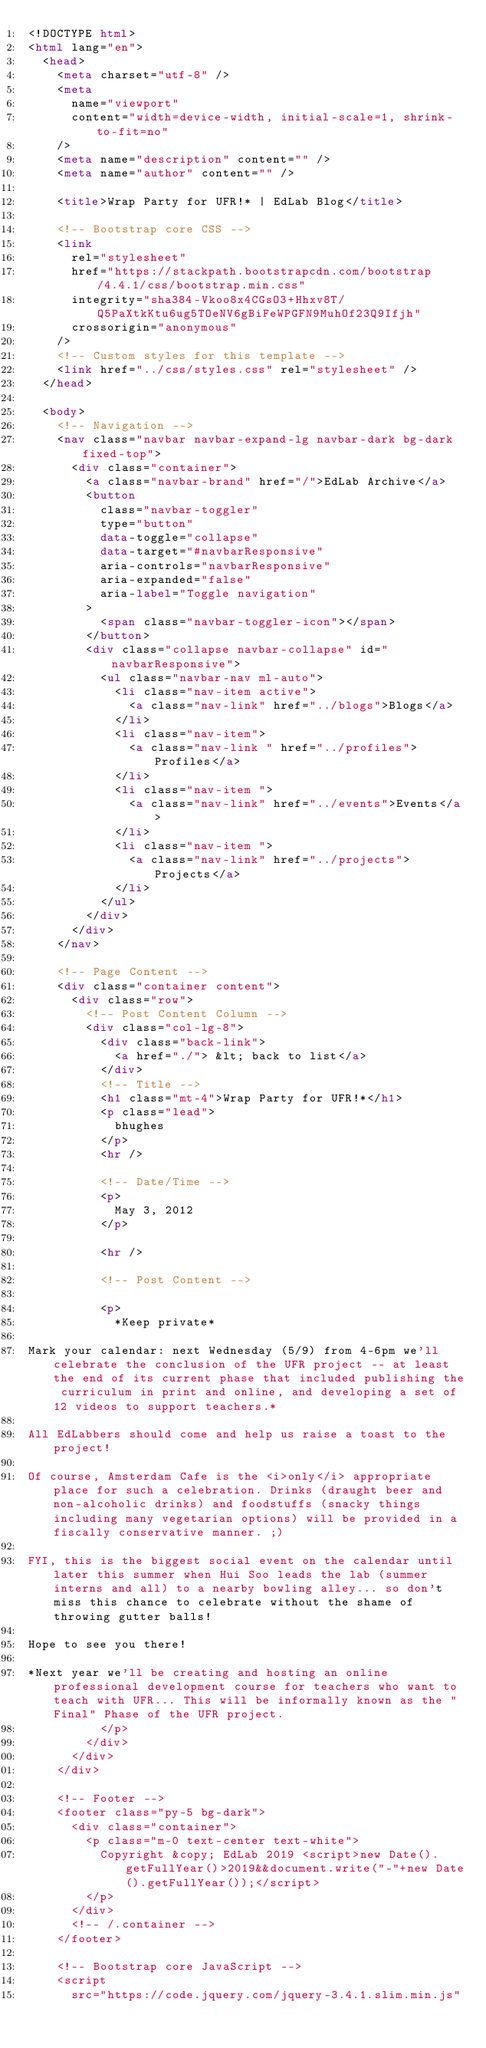Convert code to text. <code><loc_0><loc_0><loc_500><loc_500><_HTML_><!DOCTYPE html>
<html lang="en">
  <head>
    <meta charset="utf-8" />
    <meta
      name="viewport"
      content="width=device-width, initial-scale=1, shrink-to-fit=no"
    />
    <meta name="description" content="" />
    <meta name="author" content="" />

    <title>Wrap Party for UFR!* | EdLab Blog</title>

    <!-- Bootstrap core CSS -->
    <link
      rel="stylesheet"
      href="https://stackpath.bootstrapcdn.com/bootstrap/4.4.1/css/bootstrap.min.css"
      integrity="sha384-Vkoo8x4CGsO3+Hhxv8T/Q5PaXtkKtu6ug5TOeNV6gBiFeWPGFN9MuhOf23Q9Ifjh"
      crossorigin="anonymous"
    />
    <!-- Custom styles for this template -->
    <link href="../css/styles.css" rel="stylesheet" />
  </head>

  <body>
    <!-- Navigation -->
    <nav class="navbar navbar-expand-lg navbar-dark bg-dark fixed-top">
      <div class="container">
        <a class="navbar-brand" href="/">EdLab Archive</a>
        <button
          class="navbar-toggler"
          type="button"
          data-toggle="collapse"
          data-target="#navbarResponsive"
          aria-controls="navbarResponsive"
          aria-expanded="false"
          aria-label="Toggle navigation"
        >
          <span class="navbar-toggler-icon"></span>
        </button>
        <div class="collapse navbar-collapse" id="navbarResponsive">
          <ul class="navbar-nav ml-auto">
            <li class="nav-item active">
              <a class="nav-link" href="../blogs">Blogs</a>
            </li>
            <li class="nav-item">
              <a class="nav-link " href="../profiles">Profiles</a>
            </li>
            <li class="nav-item ">
              <a class="nav-link" href="../events">Events</a>
            </li>
            <li class="nav-item ">
              <a class="nav-link" href="../projects">Projects</a>
            </li>
          </ul>
        </div>
      </div>
    </nav>

    <!-- Page Content -->
    <div class="container content">
      <div class="row">
        <!-- Post Content Column -->
        <div class="col-lg-8">
          <div class="back-link">
            <a href="./"> &lt; back to list</a>
          </div>
          <!-- Title -->
          <h1 class="mt-4">Wrap Party for UFR!*</h1>
          <p class="lead">
            bhughes
          </p>
          <hr />

          <!-- Date/Time -->
          <p>
            May 3, 2012
          </p>

          <hr />

          <!-- Post Content -->

          <p>
            *Keep private*

Mark your calendar: next Wednesday (5/9) from 4-6pm we'll celebrate the conclusion of the UFR project -- at least the end of its current phase that included publishing the curriculum in print and online, and developing a set of 12 videos to support teachers.*

All EdLabbers should come and help us raise a toast to the project!

Of course, Amsterdam Cafe is the <i>only</i> appropriate place for such a celebration. Drinks (draught beer and non-alcoholic drinks) and foodstuffs (snacky things including many vegetarian options) will be provided in a fiscally conservative manner. ;)

FYI, this is the biggest social event on the calendar until later this summer when Hui Soo leads the lab (summer interns and all) to a nearby bowling alley... so don't miss this chance to celebrate without the shame of throwing gutter balls!

Hope to see you there!

*Next year we'll be creating and hosting an online professional development course for teachers who want to teach with UFR... This will be informally known as the "Final" Phase of the UFR project.
          </p>
        </div>
      </div>
    </div>

    <!-- Footer -->
    <footer class="py-5 bg-dark">
      <div class="container">
        <p class="m-0 text-center text-white">
          Copyright &copy; EdLab 2019 <script>new Date().getFullYear()>2019&&document.write("-"+new Date().getFullYear());</script>
        </p>
      </div>
      <!-- /.container -->
    </footer>

    <!-- Bootstrap core JavaScript -->
    <script
      src="https://code.jquery.com/jquery-3.4.1.slim.min.js"</code> 